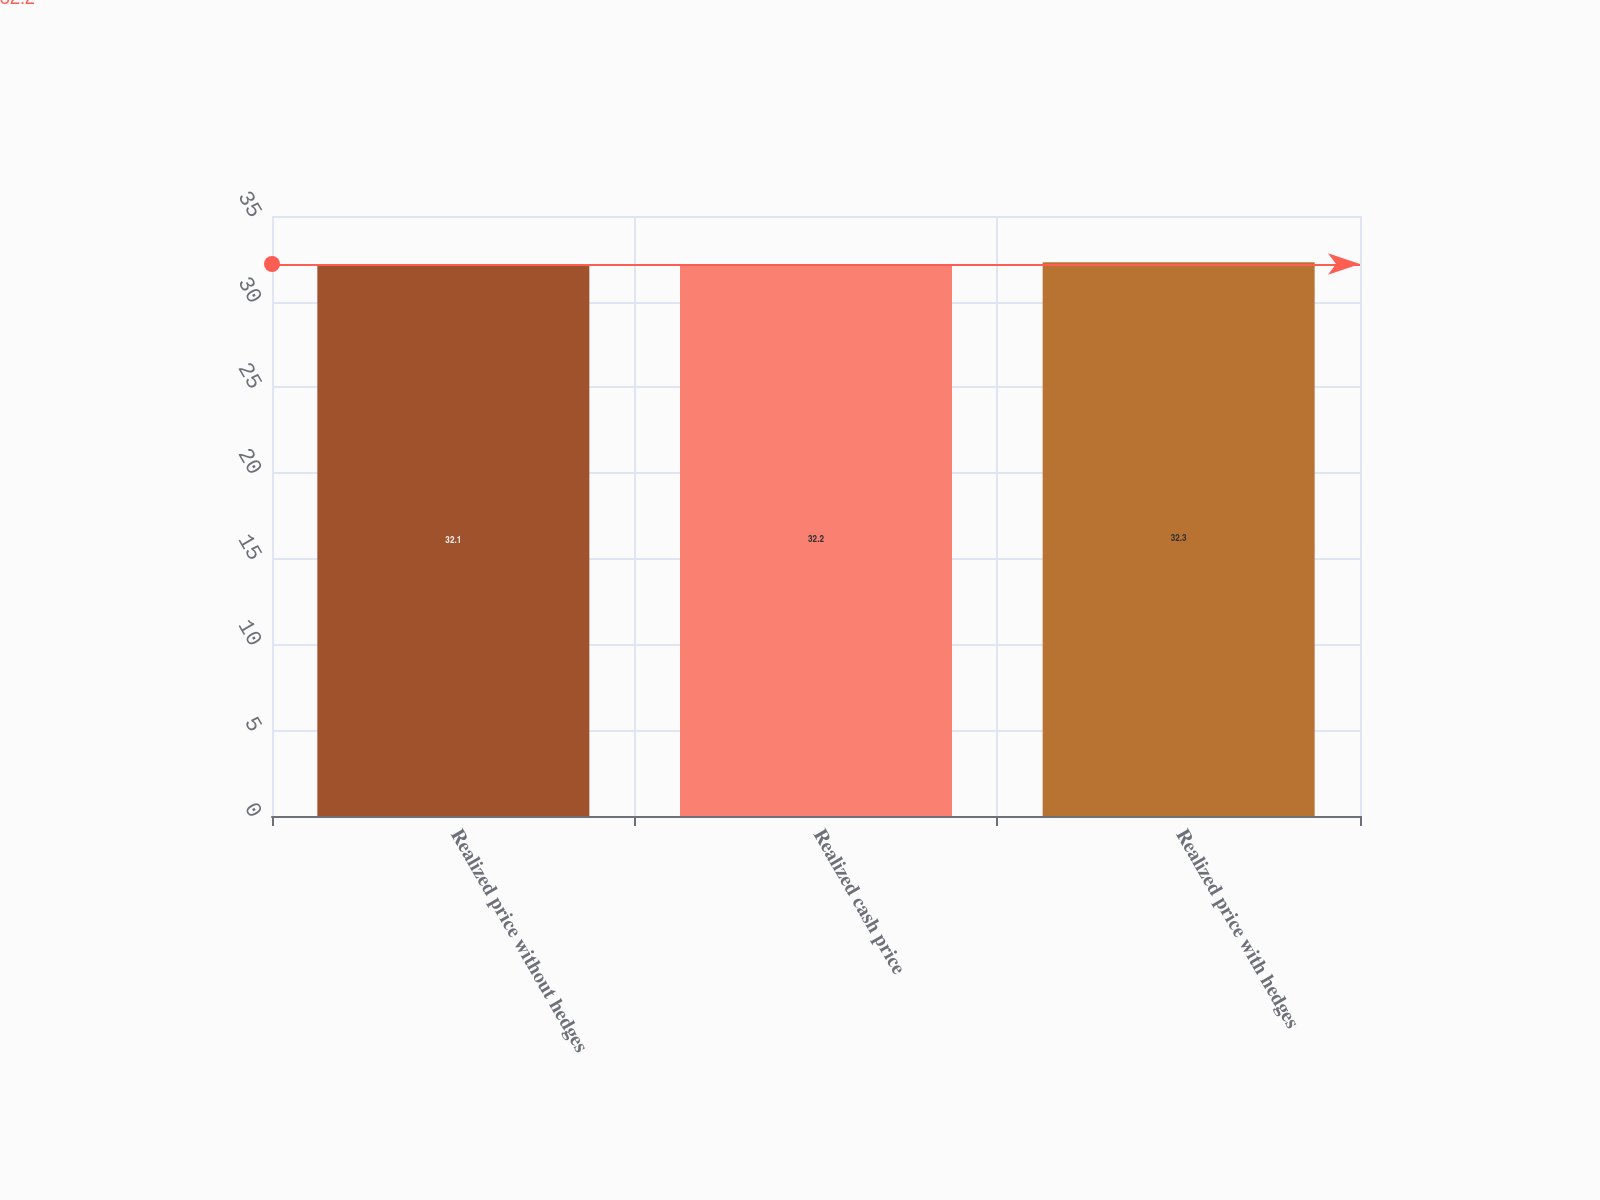<chart> <loc_0><loc_0><loc_500><loc_500><bar_chart><fcel>Realized price without hedges<fcel>Realized cash price<fcel>Realized price with hedges<nl><fcel>32.1<fcel>32.2<fcel>32.3<nl></chart> 